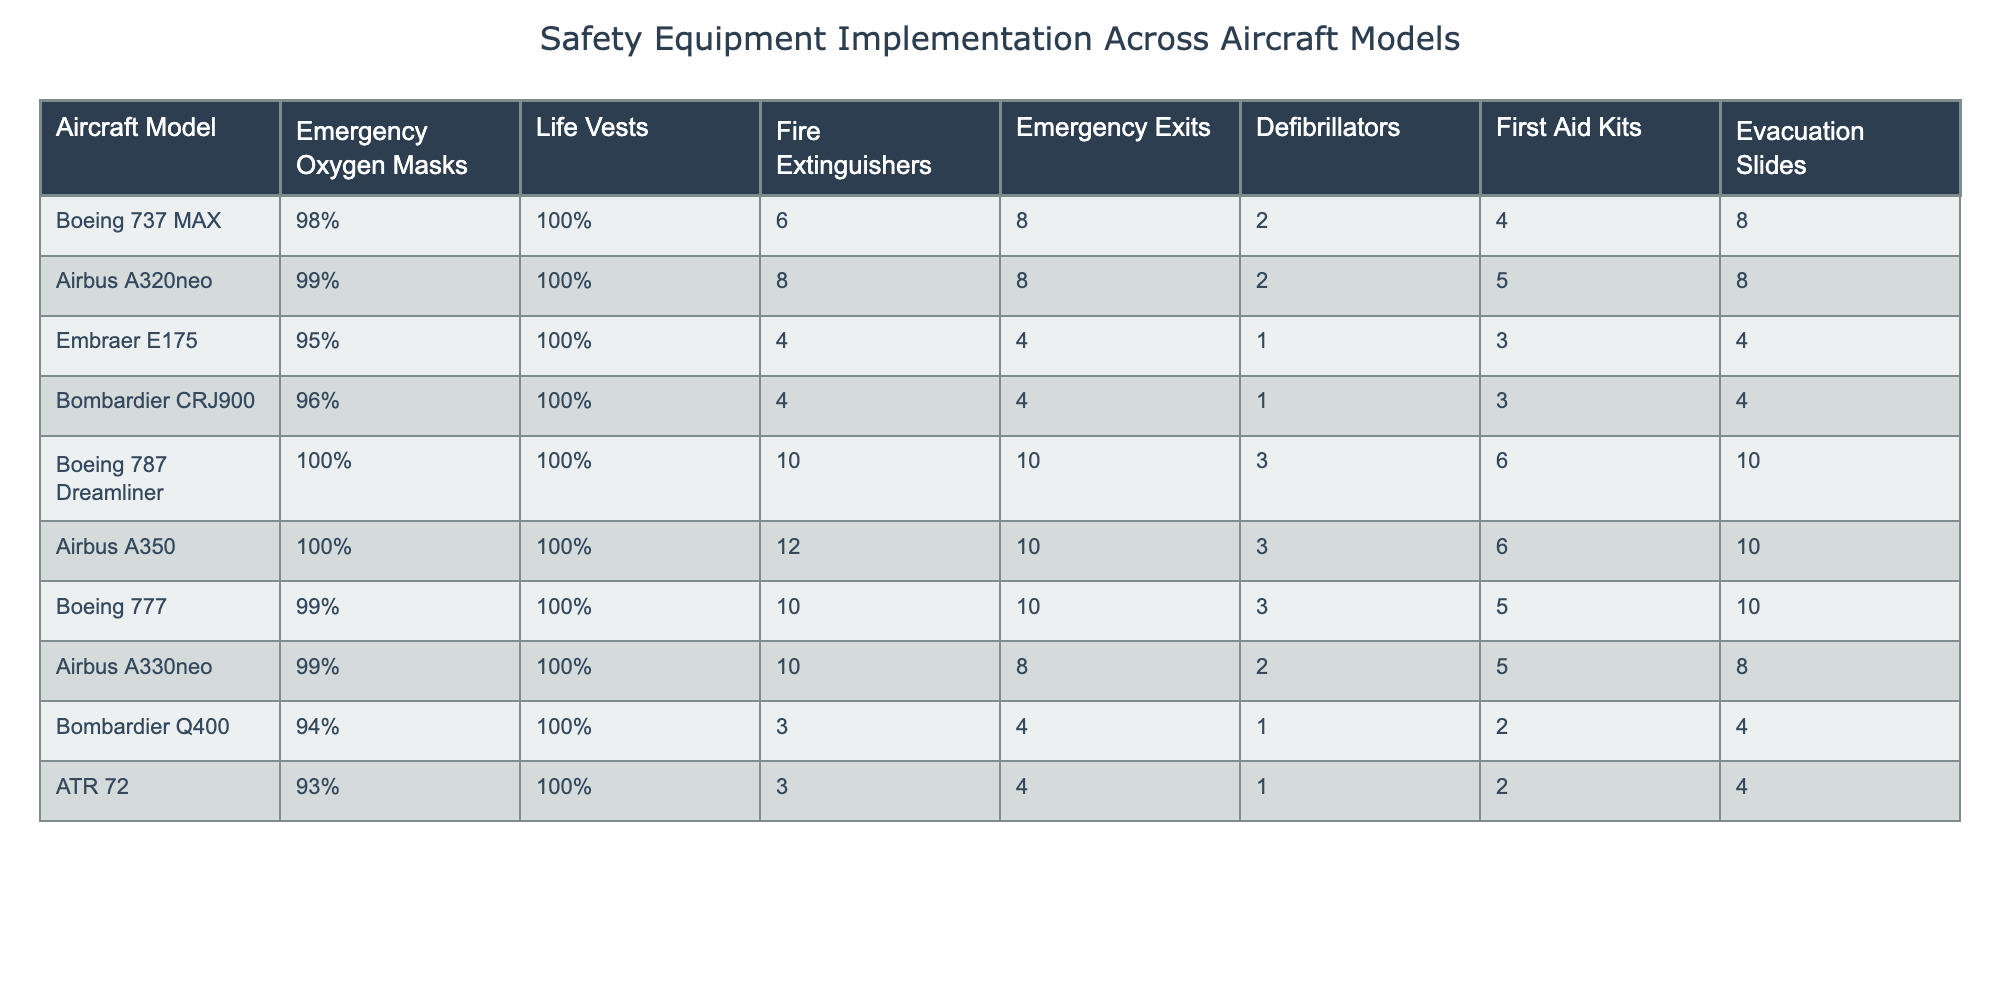What percentage of emergency oxygen masks are available on the Boeing 787 Dreamliner? The table indicates that the Boeing 787 Dreamliner has 100% of emergency oxygen masks available.
Answer: 100% Which aircraft models have the highest number of fire extinguishers? Looking through the table, the Boeing 787 Dreamliner has 10 fire extinguishers and the Airbus A350 also has 12. The highest number is 12, found on the Airbus A350.
Answer: Airbus A350 How many more evacuation slides does the Boeing 777 have compared to the Embraer E175? The Boeing 777 has 10 evacuation slides, while the Embraer E175 has 4. The difference is 10 - 4 = 6.
Answer: 6 Is the implementation of life vests consistent across all aircraft models? All aircraft models listed have 100% implementation of life vests according to the table.
Answer: Yes What is the average number of emergency exits across all aircraft models? To find the average, we add the emergency exits: (8 + 8 + 4 + 4 + 10 + 10 + 10 + 8 + 4 + 4) = 70. There are 10 aircraft models, so the average is 70 / 10 = 7.
Answer: 7 Do any aircraft models have fewer than 95% of emergency oxygen masks? The table shows that the Bombardier Q400 (94%) and ATR 72 (93%) have fewer than 95% of emergency oxygen masks available.
Answer: Yes Which model has the least number of first aid kits and how many does it have? The table indicates that both the Bombardier Q400 and ATR 72 have 2 first aid kits, which is the lowest among the listed aircraft models.
Answer: Bombardier Q400 and ATR 72, 2 What is the difference in the number of life vests between the Embraer E175 and the Airbus A320neo? Both the Embraer E175 and the Airbus A320neo have 100% life vests, thus there is no difference.
Answer: 0 Which aircraft models have both the same amount of defibrillators and first aid kits? The Boeing 737 MAX and Bombardier CRJ900 both have 2 defibrillators and 4 first aid kits.
Answer: Boeing 737 MAX and Bombardier CRJ900 